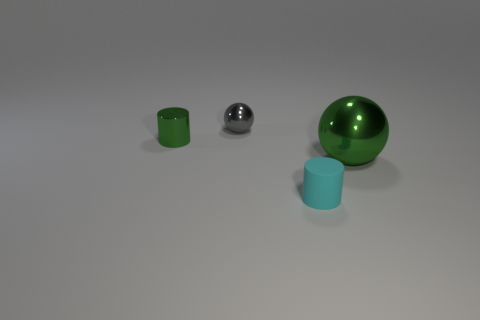Add 1 tiny gray metal things. How many objects exist? 5 Subtract 2 cylinders. How many cylinders are left? 0 Subtract all cyan cylinders. How many cylinders are left? 1 Subtract all purple blocks. How many cyan cylinders are left? 1 Subtract all tiny objects. Subtract all tiny blue metallic cylinders. How many objects are left? 1 Add 3 small cylinders. How many small cylinders are left? 5 Add 1 big blue metal balls. How many big blue metal balls exist? 1 Subtract 0 blue cylinders. How many objects are left? 4 Subtract all blue balls. Subtract all blue blocks. How many balls are left? 2 